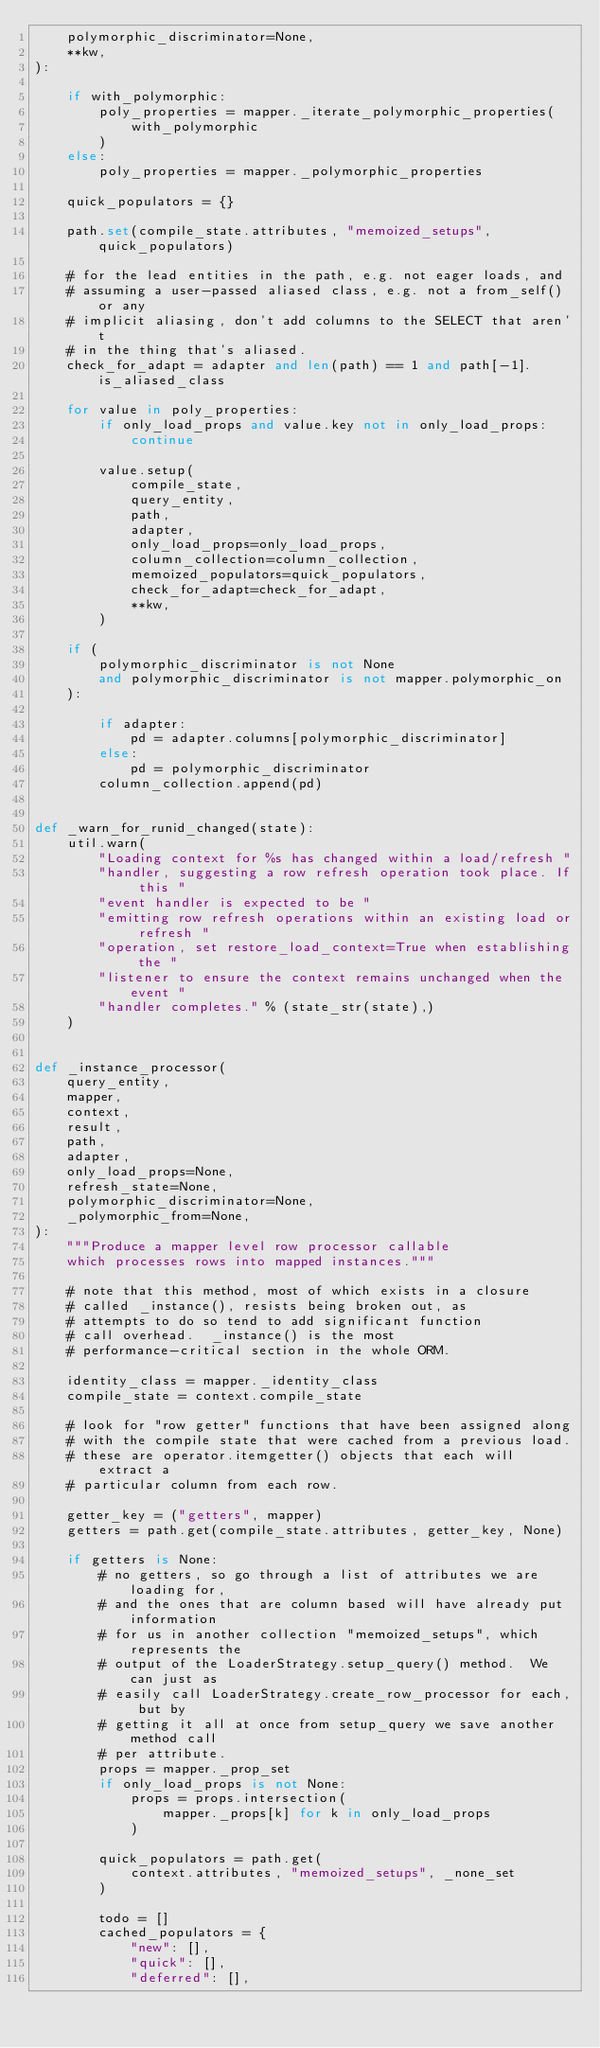Convert code to text. <code><loc_0><loc_0><loc_500><loc_500><_Python_>    polymorphic_discriminator=None,
    **kw,
):

    if with_polymorphic:
        poly_properties = mapper._iterate_polymorphic_properties(
            with_polymorphic
        )
    else:
        poly_properties = mapper._polymorphic_properties

    quick_populators = {}

    path.set(compile_state.attributes, "memoized_setups", quick_populators)

    # for the lead entities in the path, e.g. not eager loads, and
    # assuming a user-passed aliased class, e.g. not a from_self() or any
    # implicit aliasing, don't add columns to the SELECT that aren't
    # in the thing that's aliased.
    check_for_adapt = adapter and len(path) == 1 and path[-1].is_aliased_class

    for value in poly_properties:
        if only_load_props and value.key not in only_load_props:
            continue

        value.setup(
            compile_state,
            query_entity,
            path,
            adapter,
            only_load_props=only_load_props,
            column_collection=column_collection,
            memoized_populators=quick_populators,
            check_for_adapt=check_for_adapt,
            **kw,
        )

    if (
        polymorphic_discriminator is not None
        and polymorphic_discriminator is not mapper.polymorphic_on
    ):

        if adapter:
            pd = adapter.columns[polymorphic_discriminator]
        else:
            pd = polymorphic_discriminator
        column_collection.append(pd)


def _warn_for_runid_changed(state):
    util.warn(
        "Loading context for %s has changed within a load/refresh "
        "handler, suggesting a row refresh operation took place. If this "
        "event handler is expected to be "
        "emitting row refresh operations within an existing load or refresh "
        "operation, set restore_load_context=True when establishing the "
        "listener to ensure the context remains unchanged when the event "
        "handler completes." % (state_str(state),)
    )


def _instance_processor(
    query_entity,
    mapper,
    context,
    result,
    path,
    adapter,
    only_load_props=None,
    refresh_state=None,
    polymorphic_discriminator=None,
    _polymorphic_from=None,
):
    """Produce a mapper level row processor callable
    which processes rows into mapped instances."""

    # note that this method, most of which exists in a closure
    # called _instance(), resists being broken out, as
    # attempts to do so tend to add significant function
    # call overhead.  _instance() is the most
    # performance-critical section in the whole ORM.

    identity_class = mapper._identity_class
    compile_state = context.compile_state

    # look for "row getter" functions that have been assigned along
    # with the compile state that were cached from a previous load.
    # these are operator.itemgetter() objects that each will extract a
    # particular column from each row.

    getter_key = ("getters", mapper)
    getters = path.get(compile_state.attributes, getter_key, None)

    if getters is None:
        # no getters, so go through a list of attributes we are loading for,
        # and the ones that are column based will have already put information
        # for us in another collection "memoized_setups", which represents the
        # output of the LoaderStrategy.setup_query() method.  We can just as
        # easily call LoaderStrategy.create_row_processor for each, but by
        # getting it all at once from setup_query we save another method call
        # per attribute.
        props = mapper._prop_set
        if only_load_props is not None:
            props = props.intersection(
                mapper._props[k] for k in only_load_props
            )

        quick_populators = path.get(
            context.attributes, "memoized_setups", _none_set
        )

        todo = []
        cached_populators = {
            "new": [],
            "quick": [],
            "deferred": [],</code> 